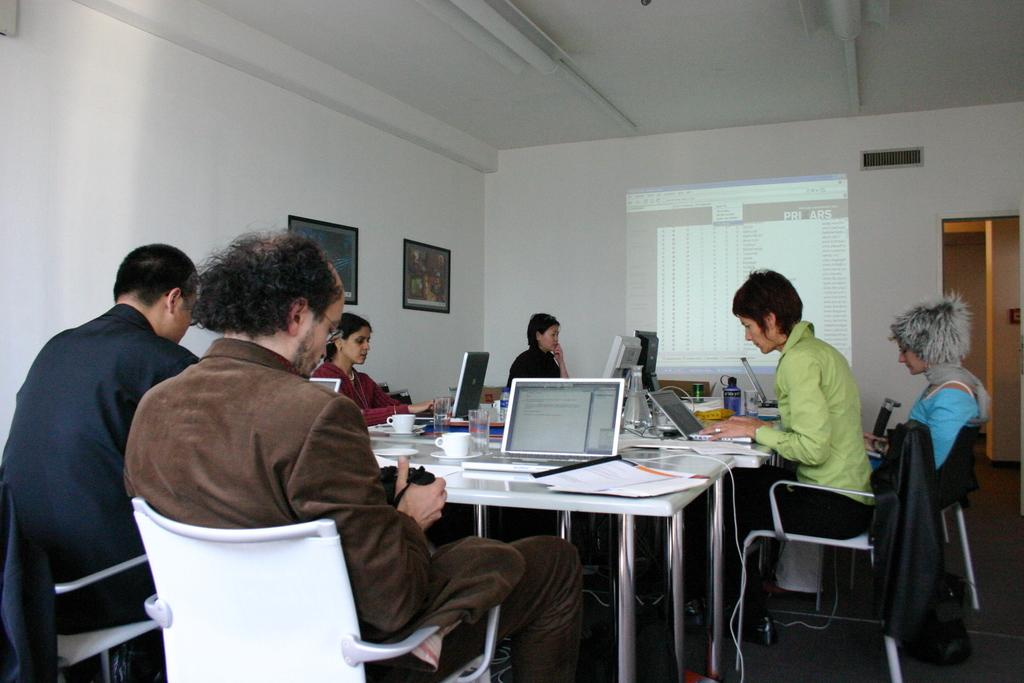How many people are present in the image? There are six people in the image. What are the people doing in the image? The people are working around a table. What objects are in front of each person? Each person has a laptop in front of them. What is the gender distribution of the people in the image? Four of the people are women, and two of the people are men. What songs are the people singing in the image? There is no indication in the image that the people are singing songs. --- Facts: 1. There is a car in the image. 2. The car is parked on the street. 3. The car is red. 4. There are trees in the background. 5. The sky is visible in the image. Absurd Topics: fish, dance, ocean Conversation: What is the main subject of the image? The main subject of the image is a car. Where is the car located in the image? The car is parked on the street. What color is the car? The car is red. What can be seen in the background of the image? There are trees in the background. What is visible at the top of the image? The sky is visible in the image. Reasoning: Let's think step by step in order to produce the conversation. We start by identifying the main subject of the image, which is the car. Then, we describe the car's location, color, and the background elements. Finally, we mention the sky visible at the top of the image. Absurd Question/Answer: Can you see any fish swimming in the ocean in the image? There is no ocean or fish present in the image; it features a red car parked on the street with trees and the sky visible in the background. 